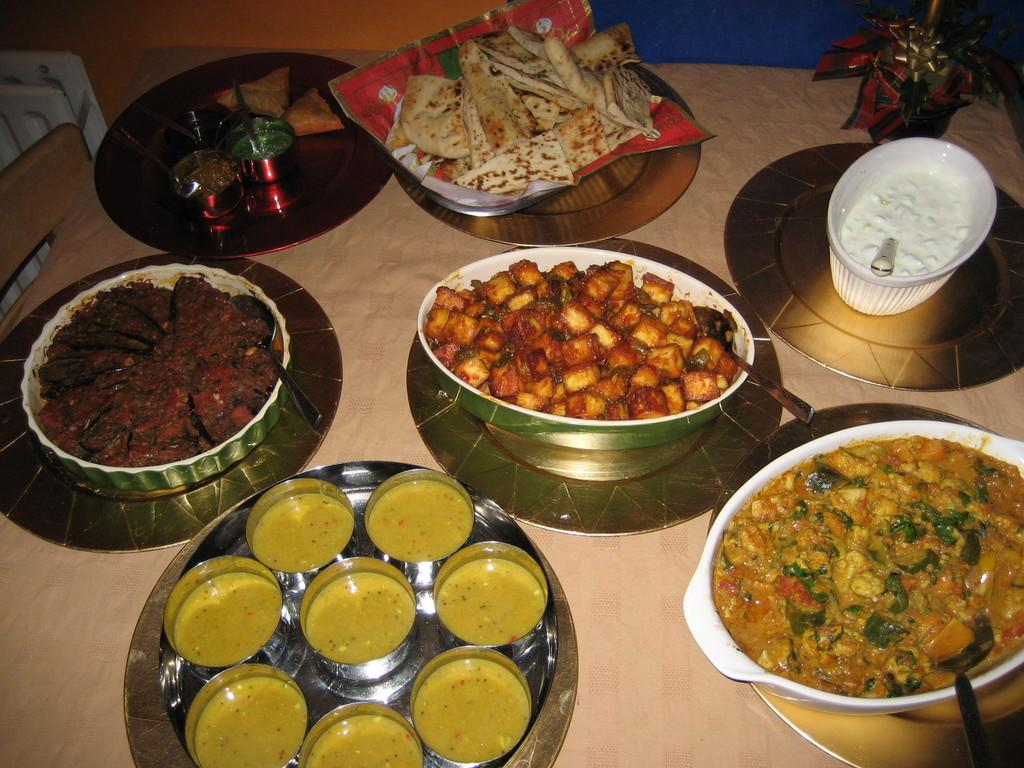What is in the bowls that are visible in the image? There are bowls with food in the image. Where are the bowls located in the image? The bowls are placed on a table in the image. What utensils are visible in the image? There are spoons visible in the image. What else is present on the table besides the bowls and spoons? There are plates in the image. What can be seen in the top right corner of the image? There is a decorative element at the top right of the image. What expert: Can you tell me which expert is advising the people in the image? There is no expert present in the image; it features bowls with food, spoons, plates, and a decorative element on a table. 